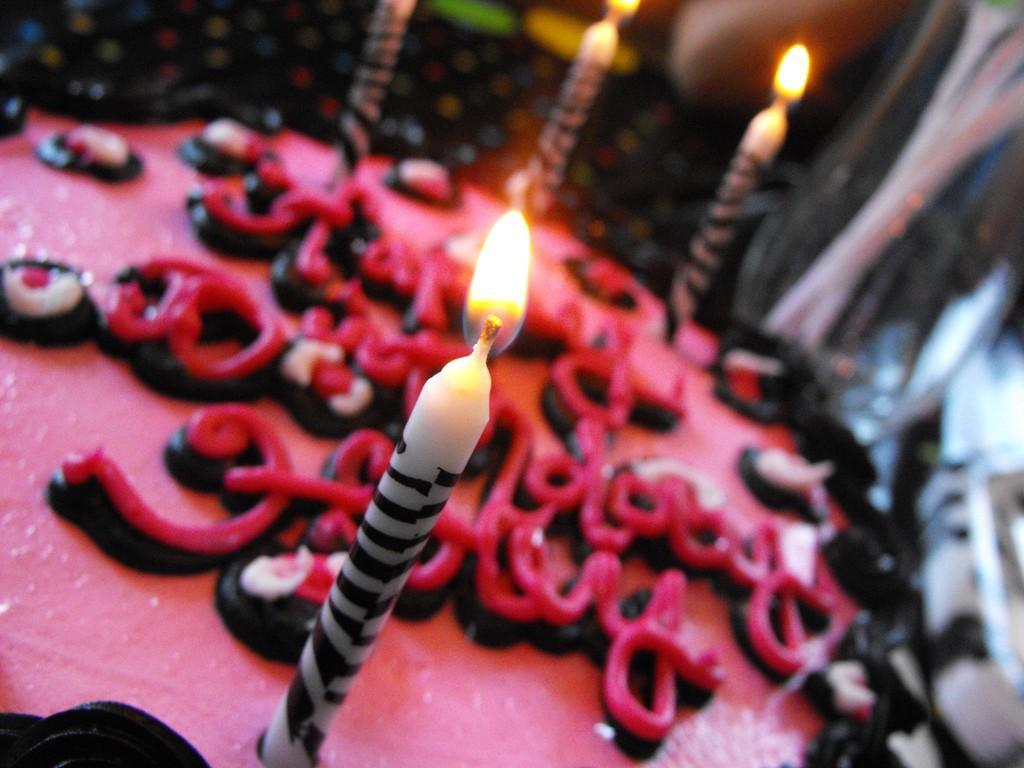In one or two sentences, can you explain what this image depicts? In this picture we can see a cake and candles. Background portion of the picture is blur. 